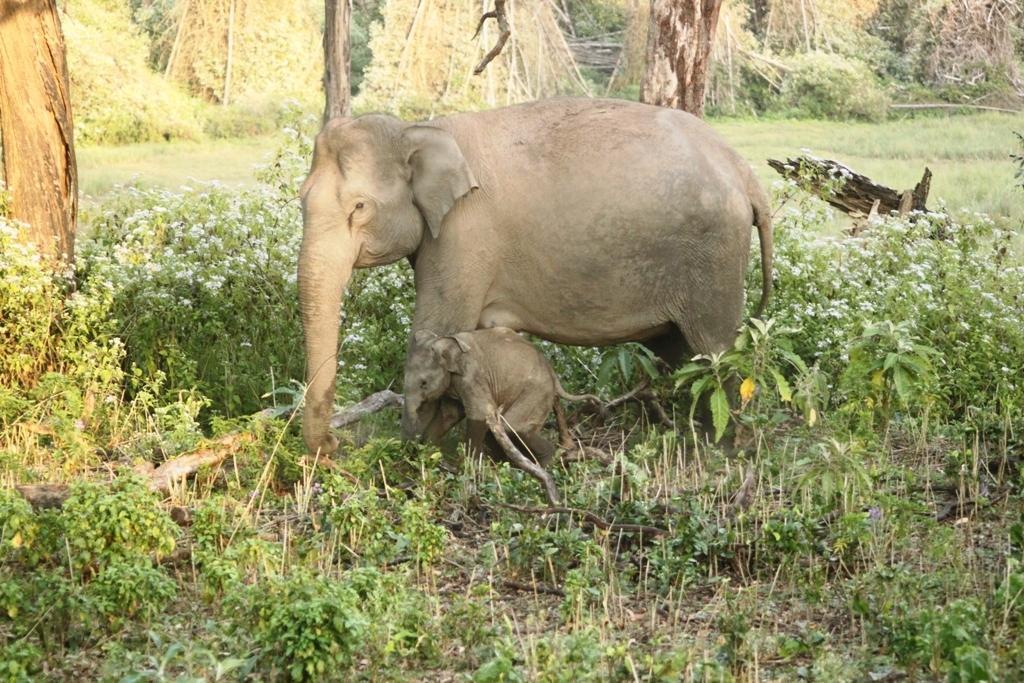Please provide a concise description of this image. In the middle of the image we can see an elephant and a calf, in this we can find few plants, flowers and trees. 